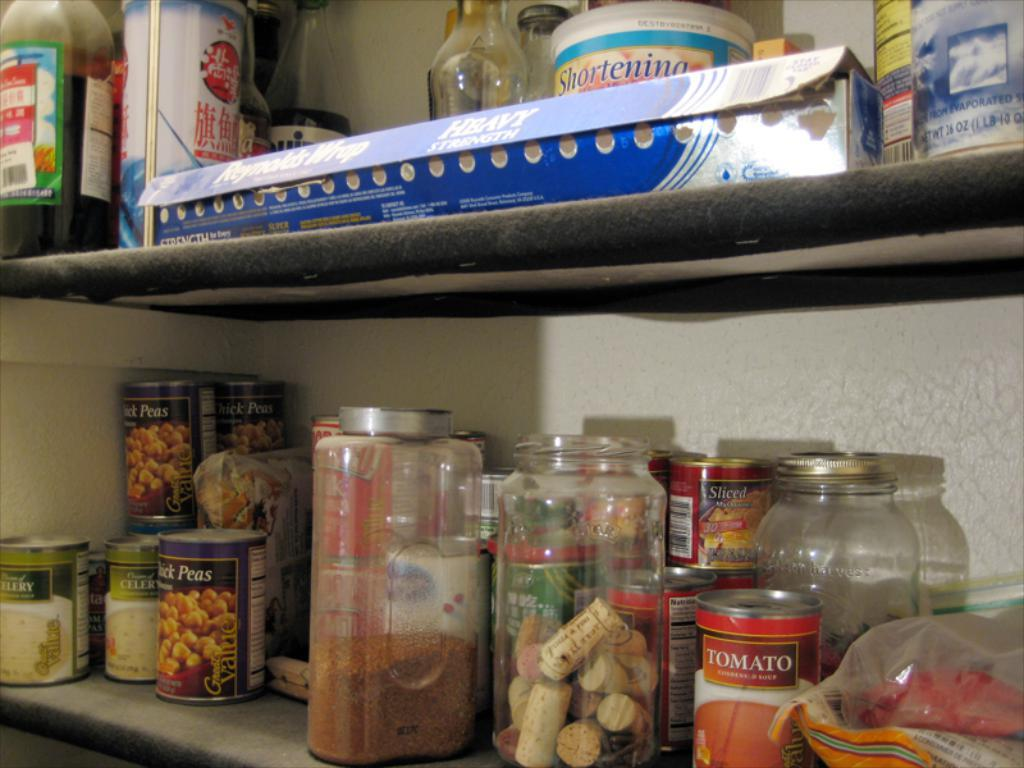What type of storage units are present in the image? There are racks in the image. What can be found on the racks? The racks contain bottles and packets. What are the bottles holding? The bottles contain items. Can you describe the reaction of the river in the image? There is no river present in the image; it only contains racks with bottles and packets. 